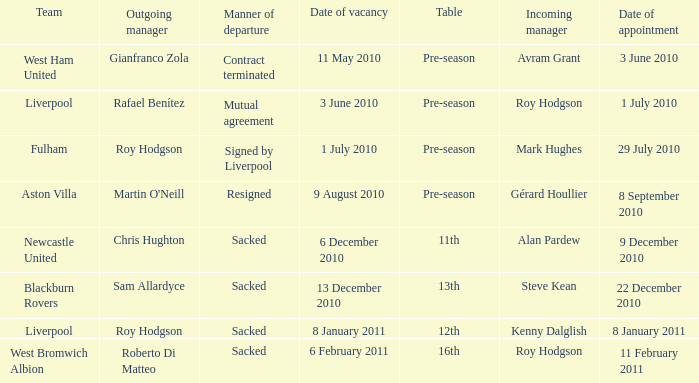Which group has a new manager called kenny dalglish? Liverpool. 